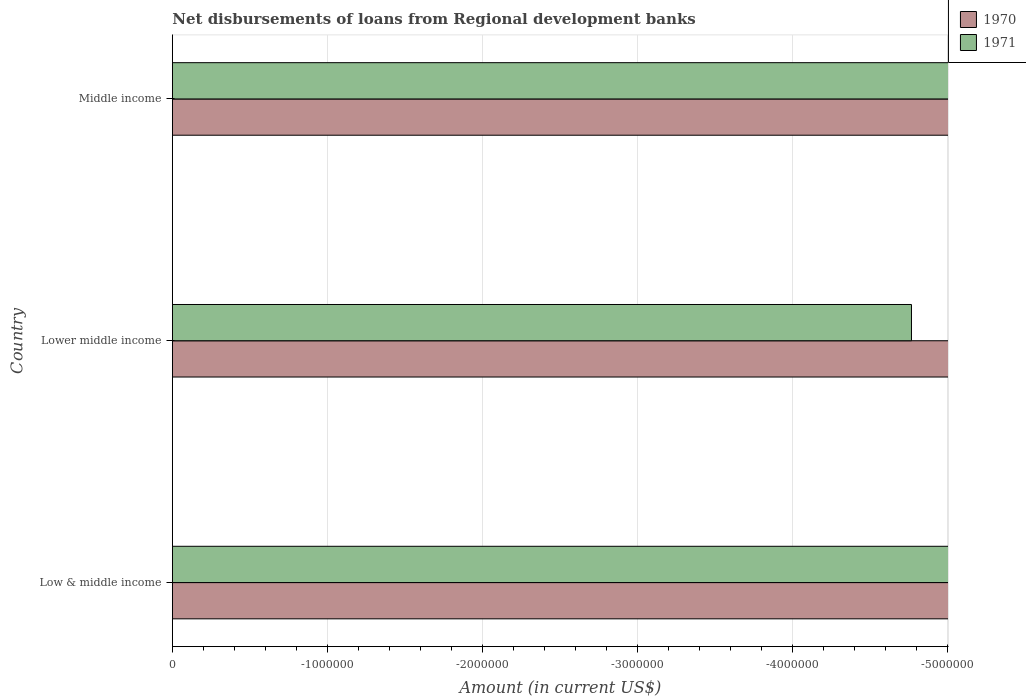How many different coloured bars are there?
Your answer should be very brief. 0. Are the number of bars per tick equal to the number of legend labels?
Give a very brief answer. No. How many bars are there on the 3rd tick from the top?
Make the answer very short. 0. How many bars are there on the 2nd tick from the bottom?
Your response must be concise. 0. What is the label of the 3rd group of bars from the top?
Offer a terse response. Low & middle income. What is the amount of disbursements of loans from regional development banks in 1970 in Lower middle income?
Keep it short and to the point. 0. What is the total amount of disbursements of loans from regional development banks in 1970 in the graph?
Provide a short and direct response. 0. In how many countries, is the amount of disbursements of loans from regional development banks in 1970 greater than the average amount of disbursements of loans from regional development banks in 1970 taken over all countries?
Ensure brevity in your answer.  0. How many countries are there in the graph?
Provide a succinct answer. 3. What is the difference between two consecutive major ticks on the X-axis?
Offer a terse response. 1.00e+06. Does the graph contain any zero values?
Keep it short and to the point. Yes. Where does the legend appear in the graph?
Your response must be concise. Top right. How many legend labels are there?
Offer a very short reply. 2. How are the legend labels stacked?
Your response must be concise. Vertical. What is the title of the graph?
Ensure brevity in your answer.  Net disbursements of loans from Regional development banks. Does "1971" appear as one of the legend labels in the graph?
Keep it short and to the point. Yes. What is the Amount (in current US$) in 1971 in Low & middle income?
Your answer should be very brief. 0. What is the Amount (in current US$) in 1970 in Middle income?
Ensure brevity in your answer.  0. What is the total Amount (in current US$) of 1970 in the graph?
Give a very brief answer. 0. What is the total Amount (in current US$) in 1971 in the graph?
Keep it short and to the point. 0. What is the average Amount (in current US$) of 1970 per country?
Offer a very short reply. 0. What is the average Amount (in current US$) in 1971 per country?
Give a very brief answer. 0. 